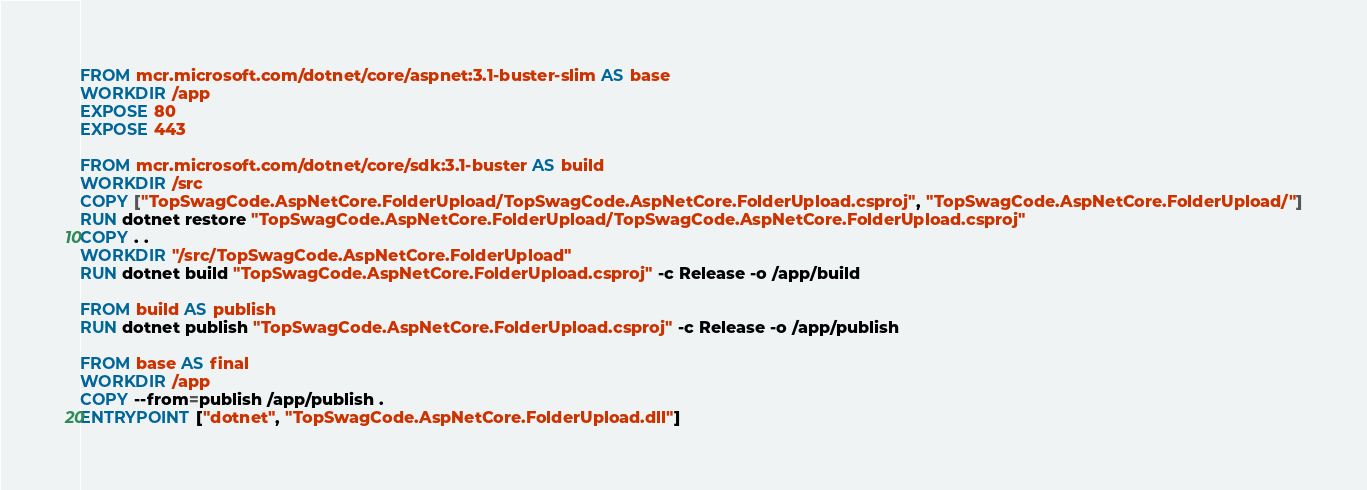Convert code to text. <code><loc_0><loc_0><loc_500><loc_500><_Dockerfile_>FROM mcr.microsoft.com/dotnet/core/aspnet:3.1-buster-slim AS base
WORKDIR /app
EXPOSE 80
EXPOSE 443

FROM mcr.microsoft.com/dotnet/core/sdk:3.1-buster AS build
WORKDIR /src
COPY ["TopSwagCode.AspNetCore.FolderUpload/TopSwagCode.AspNetCore.FolderUpload.csproj", "TopSwagCode.AspNetCore.FolderUpload/"]
RUN dotnet restore "TopSwagCode.AspNetCore.FolderUpload/TopSwagCode.AspNetCore.FolderUpload.csproj"
COPY . .
WORKDIR "/src/TopSwagCode.AspNetCore.FolderUpload"
RUN dotnet build "TopSwagCode.AspNetCore.FolderUpload.csproj" -c Release -o /app/build

FROM build AS publish
RUN dotnet publish "TopSwagCode.AspNetCore.FolderUpload.csproj" -c Release -o /app/publish

FROM base AS final
WORKDIR /app
COPY --from=publish /app/publish .
ENTRYPOINT ["dotnet", "TopSwagCode.AspNetCore.FolderUpload.dll"]</code> 